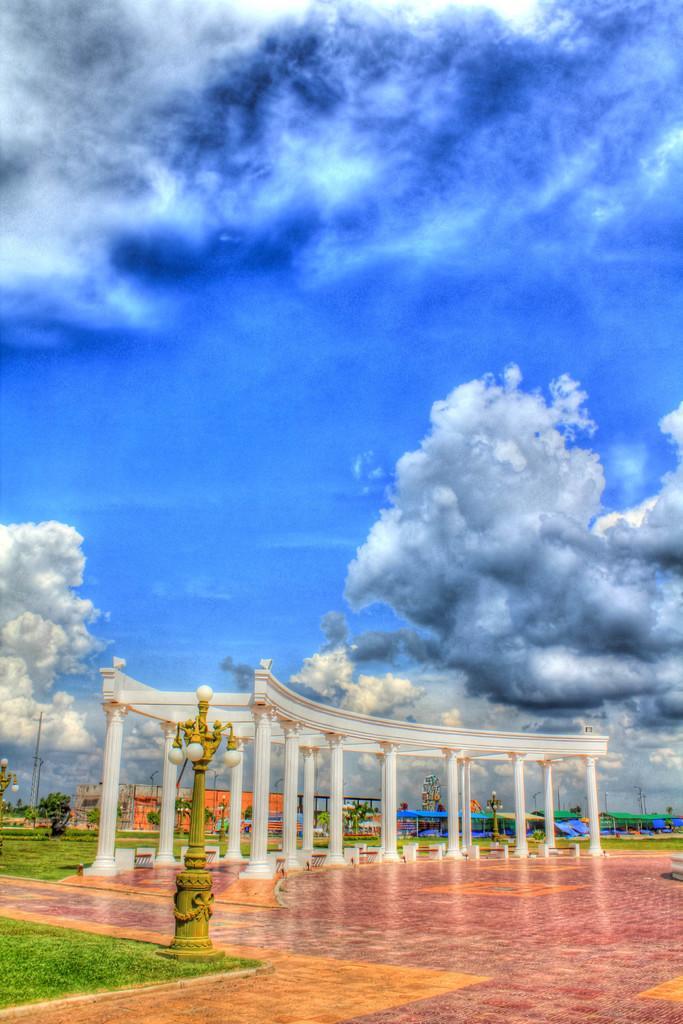Can you describe this image briefly? Here we can see pillars, poles, lights, and plants. This is grass. In the background there is sky with heavy clouds. 